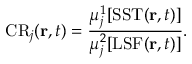Convert formula to latex. <formula><loc_0><loc_0><loc_500><loc_500>C R _ { j } ( r , t ) = \frac { \mu _ { j } ^ { 1 } [ S S T ( r , t ) ] } { \mu _ { j } ^ { 2 } [ L S F ( r , t ) ] } .</formula> 